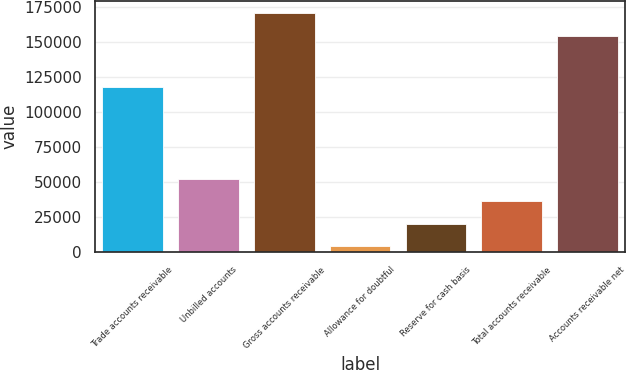Convert chart. <chart><loc_0><loc_0><loc_500><loc_500><bar_chart><fcel>Trade accounts receivable<fcel>Unbilled accounts<fcel>Gross accounts receivable<fcel>Allowance for doubtful<fcel>Reserve for cash basis<fcel>Total accounts receivable<fcel>Accounts receivable net<nl><fcel>117449<fcel>52350.3<fcel>170340<fcel>4137<fcel>20208.1<fcel>36279.2<fcel>154269<nl></chart> 